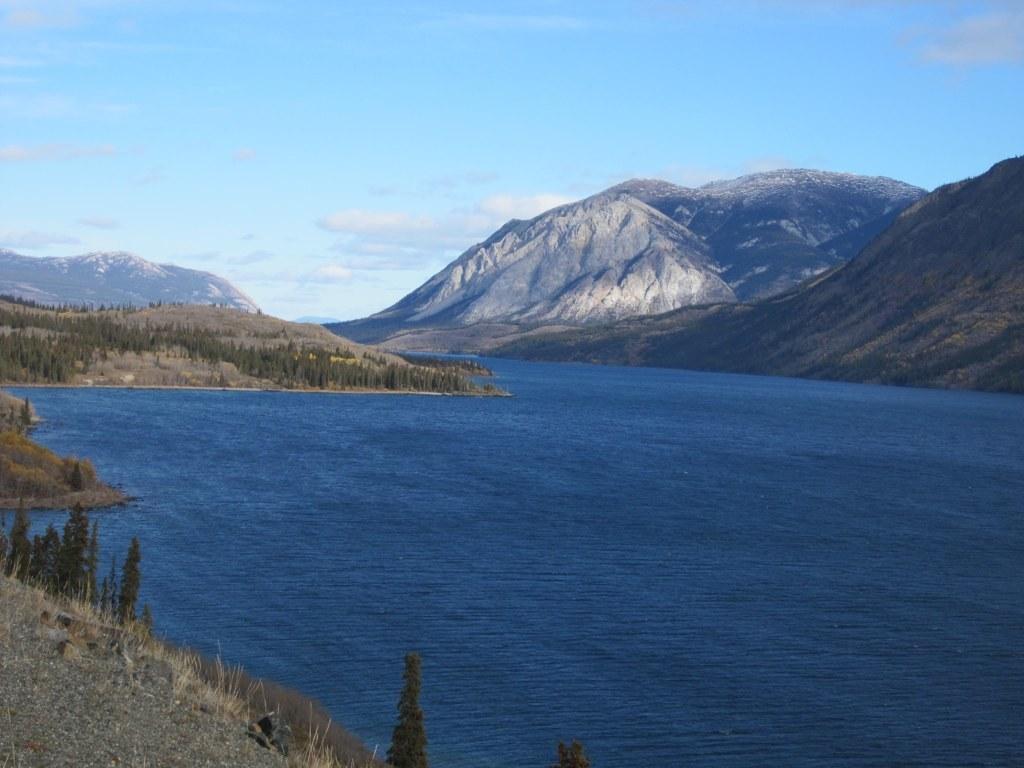How would you summarize this image in a sentence or two? In this image, we can see water, there are some mountains on the right side, we can see some plants, at the top there is a blue sky. 